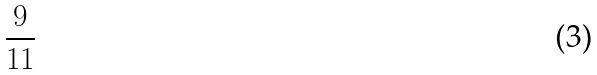Convert formula to latex. <formula><loc_0><loc_0><loc_500><loc_500>\frac { 9 } { 1 1 }</formula> 